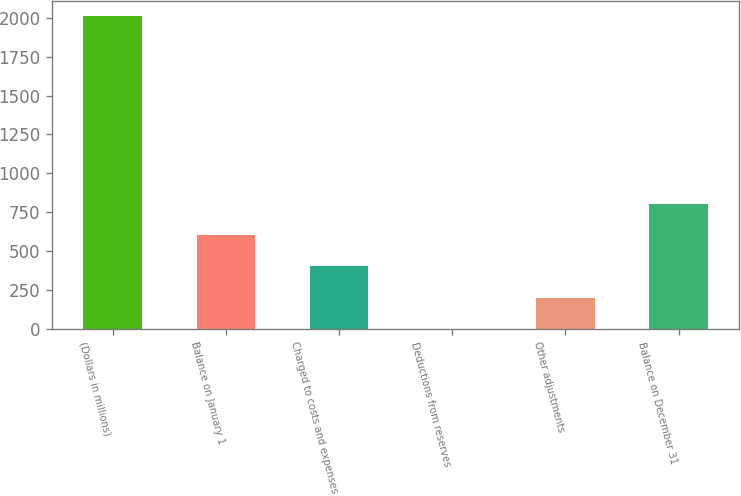Convert chart to OTSL. <chart><loc_0><loc_0><loc_500><loc_500><bar_chart><fcel>(Dollars in millions)<fcel>Balance on January 1<fcel>Charged to costs and expenses<fcel>Deductions from reserves<fcel>Other adjustments<fcel>Balance on December 31<nl><fcel>2010<fcel>603.7<fcel>402.8<fcel>1<fcel>201.9<fcel>804.6<nl></chart> 